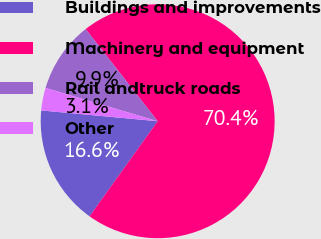Convert chart. <chart><loc_0><loc_0><loc_500><loc_500><pie_chart><fcel>Buildings and improvements<fcel>Machinery and equipment<fcel>Rail andtruck roads<fcel>Other<nl><fcel>16.58%<fcel>70.45%<fcel>9.85%<fcel>3.12%<nl></chart> 